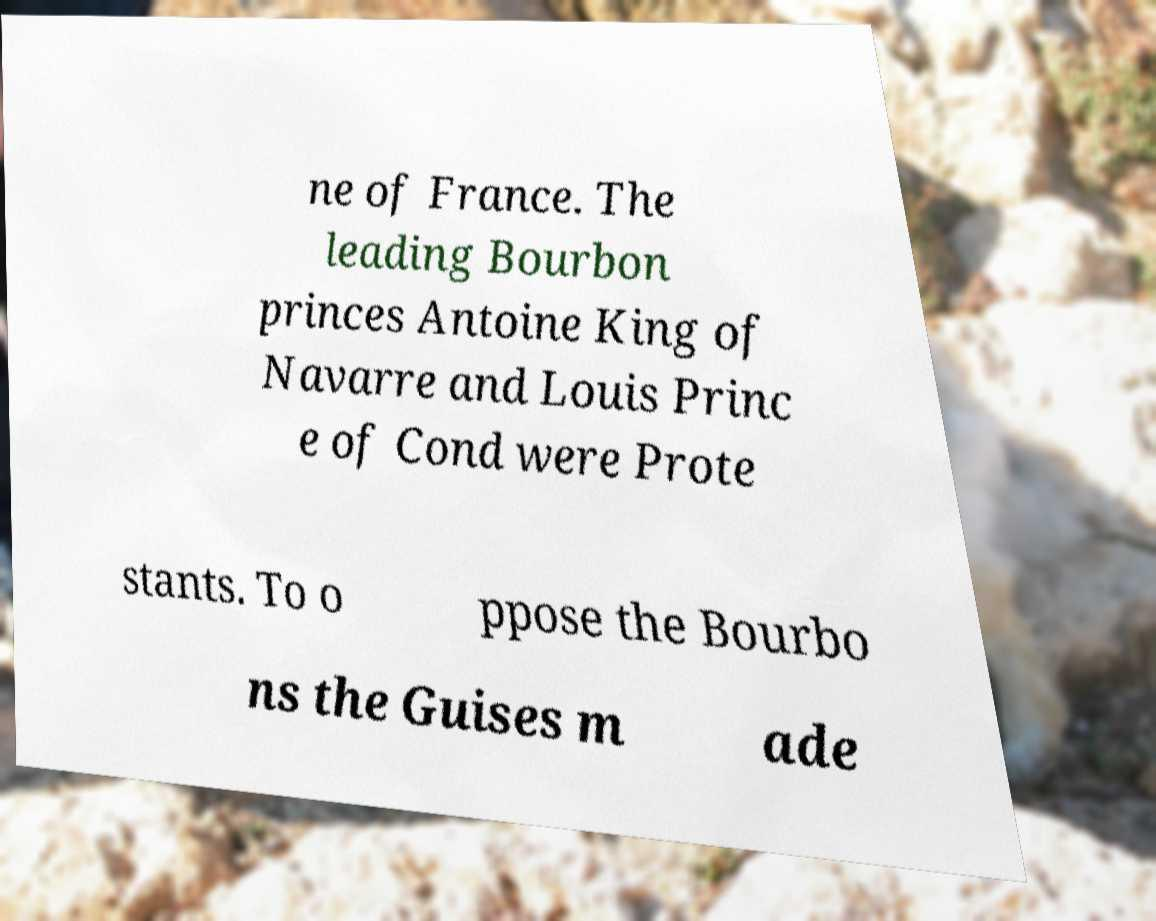Could you extract and type out the text from this image? ne of France. The leading Bourbon princes Antoine King of Navarre and Louis Princ e of Cond were Prote stants. To o ppose the Bourbo ns the Guises m ade 